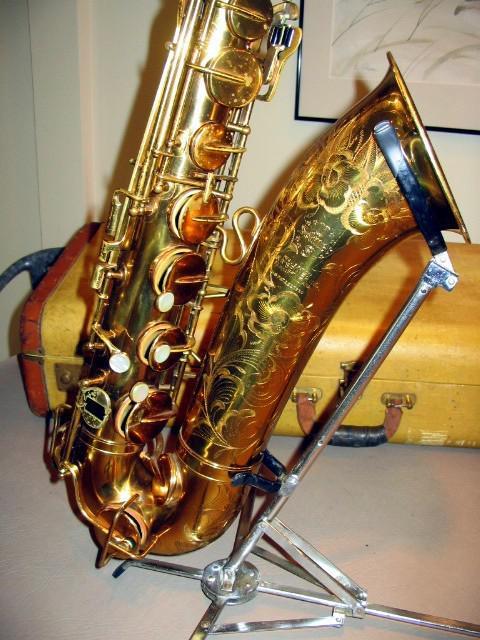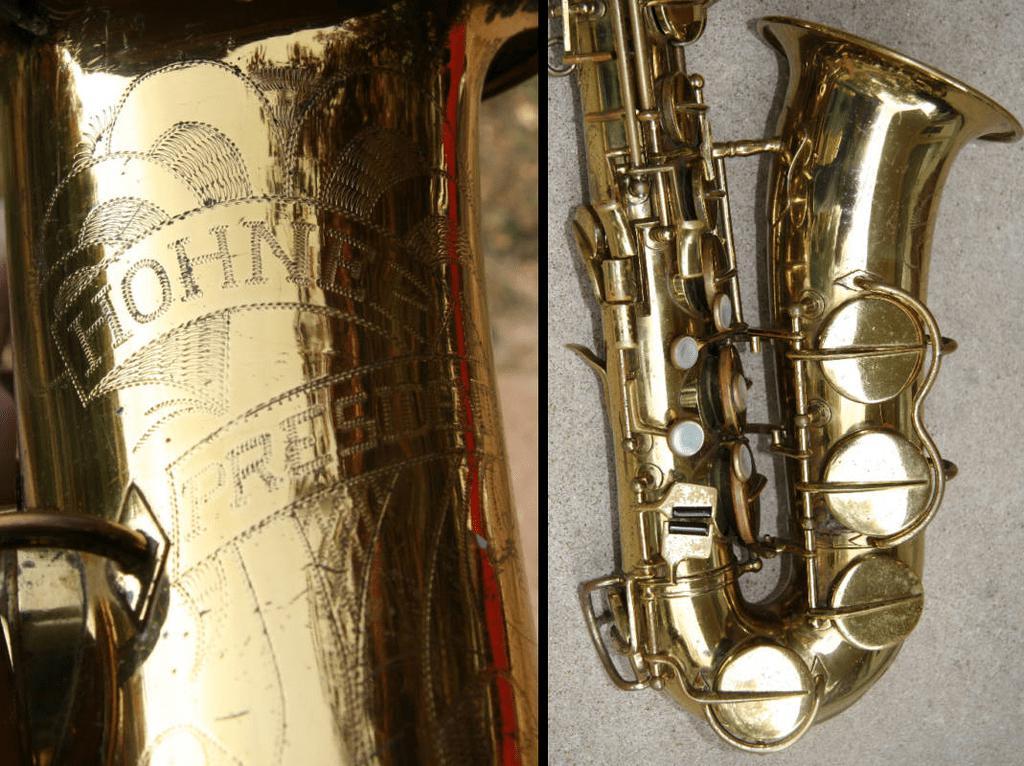The first image is the image on the left, the second image is the image on the right. Given the left and right images, does the statement "In one image, a full length saxophone is lying flat on a cloth, while a second image shows only the lower section of a silver saxophone." hold true? Answer yes or no. No. The first image is the image on the left, the second image is the image on the right. Assess this claim about the two images: "An image shows a silver saxophone in an open case lined with crushed red velvet.". Correct or not? Answer yes or no. No. 